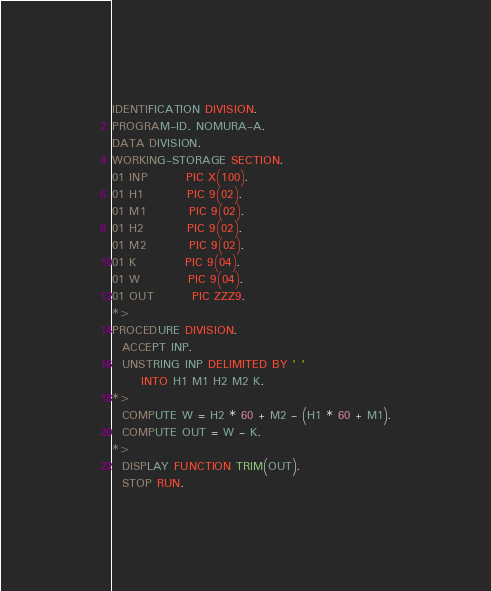Convert code to text. <code><loc_0><loc_0><loc_500><loc_500><_COBOL_>IDENTIFICATION DIVISION.
PROGRAM-ID. NOMURA-A.
DATA DIVISION.
WORKING-STORAGE SECTION.
01 INP        PIC X(100).
01 H1         PIC 9(02).
01 M1         PIC 9(02).
01 H2         PIC 9(02).
01 M2         PIC 9(02).
01 K          PIC 9(04).
01 W          PIC 9(04).
01 OUT        PIC ZZZ9.
*>
PROCEDURE DIVISION.
  ACCEPT INP.
  UNSTRING INP DELIMITED BY ' '
      INTO H1 M1 H2 M2 K.
*>
  COMPUTE W = H2 * 60 + M2 - (H1 * 60 + M1).
  COMPUTE OUT = W - K.
*>
  DISPLAY FUNCTION TRIM(OUT).
  STOP RUN.
</code> 